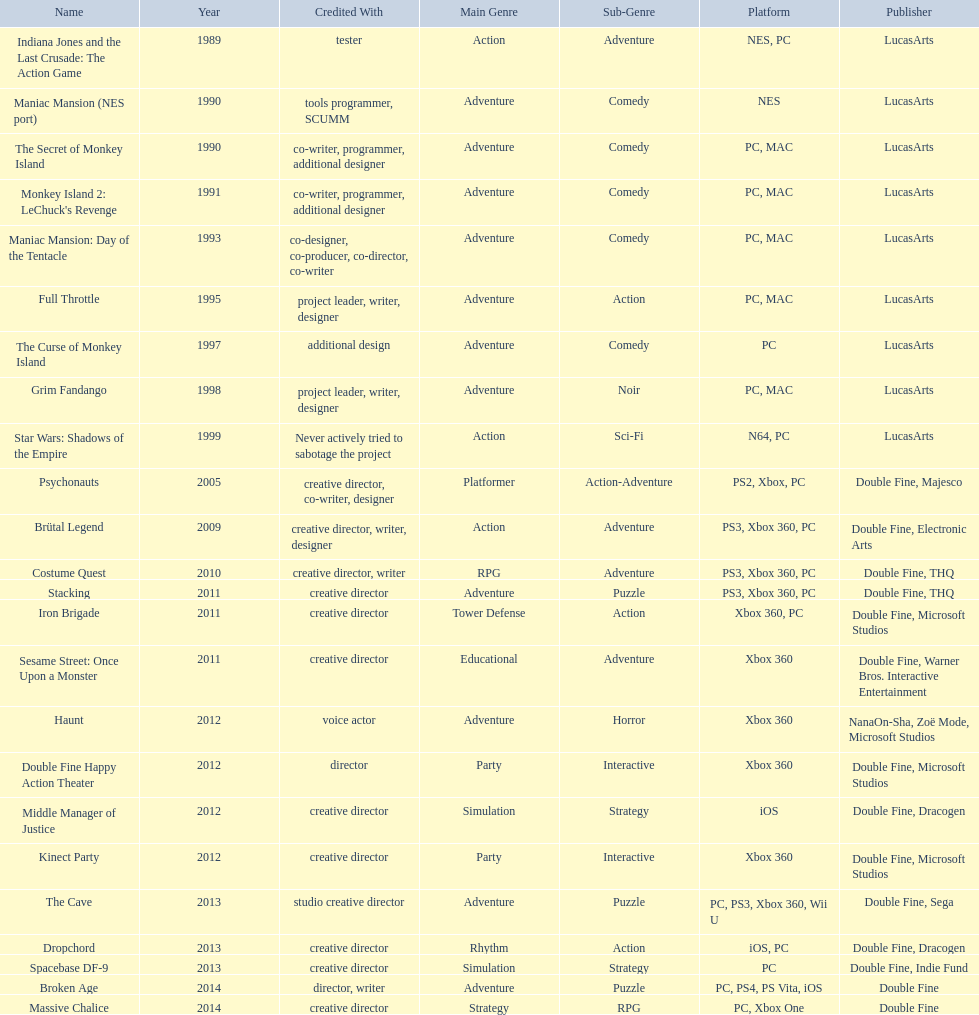Which productions did tim schafer work on that were published in part by double fine? Psychonauts, Brütal Legend, Costume Quest, Stacking, Iron Brigade, Sesame Street: Once Upon a Monster, Double Fine Happy Action Theater, Middle Manager of Justice, Kinect Party, The Cave, Dropchord, Spacebase DF-9, Broken Age, Massive Chalice. Would you be able to parse every entry in this table? {'header': ['Name', 'Year', 'Credited With', 'Main Genre', 'Sub-Genre', 'Platform', 'Publisher'], 'rows': [['Indiana Jones and the Last Crusade: The Action Game', '1989', 'tester', 'Action', 'Adventure', 'NES, PC', 'LucasArts'], ['Maniac Mansion (NES port)', '1990', 'tools programmer, SCUMM', 'Adventure', 'Comedy', 'NES', 'LucasArts'], ['The Secret of Monkey Island', '1990', 'co-writer, programmer, additional designer', 'Adventure', 'Comedy', 'PC, MAC', 'LucasArts'], ["Monkey Island 2: LeChuck's Revenge", '1991', 'co-writer, programmer, additional designer', 'Adventure', 'Comedy', 'PC, MAC', 'LucasArts'], ['Maniac Mansion: Day of the Tentacle', '1993', 'co-designer, co-producer, co-director, co-writer', 'Adventure', 'Comedy', 'PC, MAC', 'LucasArts'], ['Full Throttle', '1995', 'project leader, writer, designer', 'Adventure', 'Action', 'PC, MAC', 'LucasArts'], ['The Curse of Monkey Island', '1997', 'additional design', 'Adventure', 'Comedy', 'PC', 'LucasArts'], ['Grim Fandango', '1998', 'project leader, writer, designer', 'Adventure', 'Noir', 'PC, MAC', 'LucasArts'], ['Star Wars: Shadows of the Empire', '1999', 'Never actively tried to sabotage the project', 'Action', 'Sci-Fi', 'N64, PC', 'LucasArts'], ['Psychonauts', '2005', 'creative director, co-writer, designer', 'Platformer', 'Action-Adventure', 'PS2, Xbox, PC', 'Double Fine, Majesco'], ['Brütal Legend', '2009', 'creative director, writer, designer', 'Action', 'Adventure', 'PS3, Xbox 360, PC', 'Double Fine, Electronic Arts'], ['Costume Quest', '2010', 'creative director, writer', 'RPG', 'Adventure', 'PS3, Xbox 360, PC', 'Double Fine, THQ'], ['Stacking', '2011', 'creative director', 'Adventure', 'Puzzle', 'PS3, Xbox 360, PC', 'Double Fine, THQ'], ['Iron Brigade', '2011', 'creative director', 'Tower Defense', 'Action', 'Xbox 360, PC', 'Double Fine, Microsoft Studios'], ['Sesame Street: Once Upon a Monster', '2011', 'creative director', 'Educational', 'Adventure', 'Xbox 360', 'Double Fine, Warner Bros. Interactive Entertainment'], ['Haunt', '2012', 'voice actor', 'Adventure', 'Horror', 'Xbox 360', 'NanaOn-Sha, Zoë Mode, Microsoft Studios'], ['Double Fine Happy Action Theater', '2012', 'director', 'Party', 'Interactive', 'Xbox 360', 'Double Fine, Microsoft Studios'], ['Middle Manager of Justice', '2012', 'creative director', 'Simulation', 'Strategy', 'iOS', 'Double Fine, Dracogen'], ['Kinect Party', '2012', 'creative director', 'Party', 'Interactive', 'Xbox 360', 'Double Fine, Microsoft Studios'], ['The Cave', '2013', 'studio creative director', 'Adventure', 'Puzzle', 'PC, PS3, Xbox 360, Wii U', 'Double Fine, Sega'], ['Dropchord', '2013', 'creative director', 'Rhythm', 'Action', 'iOS, PC', 'Double Fine, Dracogen'], ['Spacebase DF-9', '2013', 'creative director', 'Simulation', 'Strategy', 'PC', 'Double Fine, Indie Fund'], ['Broken Age', '2014', 'director, writer', 'Adventure', 'Puzzle', 'PC, PS4, PS Vita, iOS', 'Double Fine'], ['Massive Chalice', '2014', 'creative director', 'Strategy', 'RPG', 'PC, Xbox One', 'Double Fine']]} Which of these was he a creative director? Psychonauts, Brütal Legend, Costume Quest, Stacking, Iron Brigade, Sesame Street: Once Upon a Monster, Middle Manager of Justice, Kinect Party, The Cave, Dropchord, Spacebase DF-9, Massive Chalice. Which of those were in 2011? Stacking, Iron Brigade, Sesame Street: Once Upon a Monster. What was the only one of these to be co published by warner brothers? Sesame Street: Once Upon a Monster. 